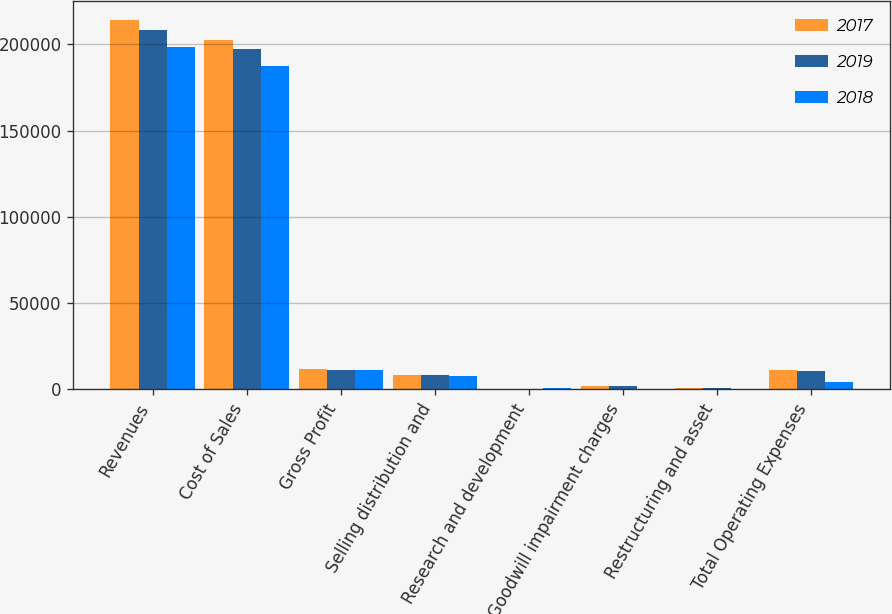Convert chart to OTSL. <chart><loc_0><loc_0><loc_500><loc_500><stacked_bar_chart><ecel><fcel>Revenues<fcel>Cost of Sales<fcel>Gross Profit<fcel>Selling distribution and<fcel>Research and development<fcel>Goodwill impairment charges<fcel>Restructuring and asset<fcel>Total Operating Expenses<nl><fcel>2017<fcel>214319<fcel>202565<fcel>11754<fcel>8403<fcel>71<fcel>1797<fcel>597<fcel>10868<nl><fcel>2019<fcel>208357<fcel>197173<fcel>11184<fcel>8138<fcel>125<fcel>1738<fcel>567<fcel>10422<nl><fcel>2018<fcel>198533<fcel>187262<fcel>11271<fcel>7447<fcel>341<fcel>290<fcel>18<fcel>4149<nl></chart> 